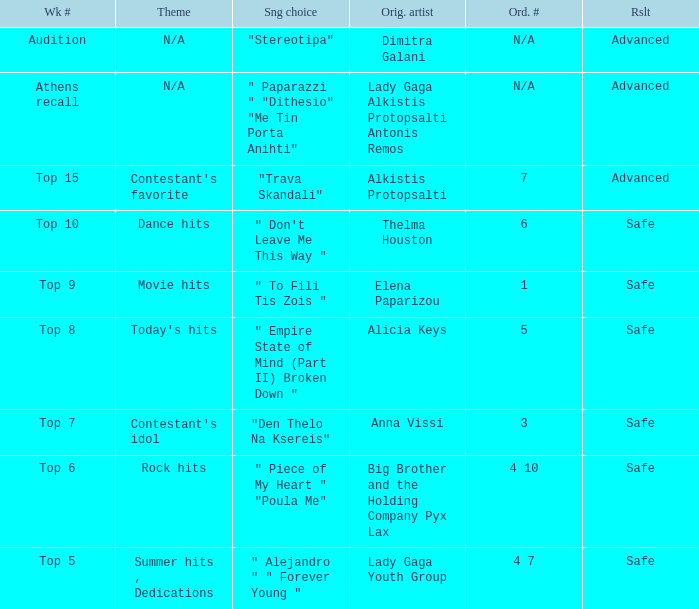Which artists have order # 1? Elena Paparizou. 